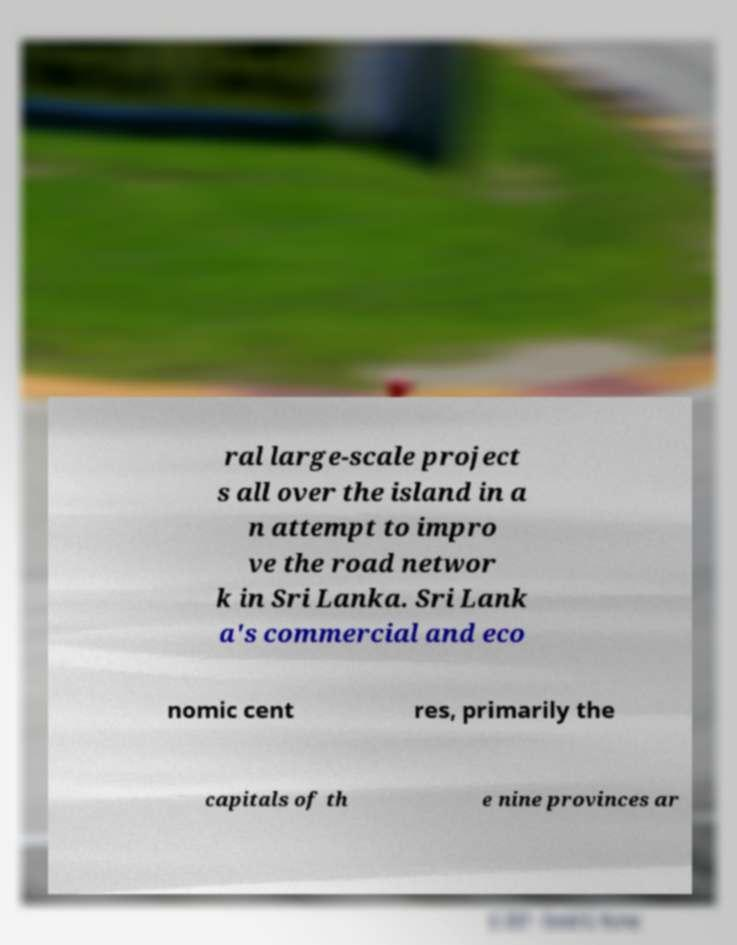What messages or text are displayed in this image? I need them in a readable, typed format. ral large-scale project s all over the island in a n attempt to impro ve the road networ k in Sri Lanka. Sri Lank a's commercial and eco nomic cent res, primarily the capitals of th e nine provinces ar 